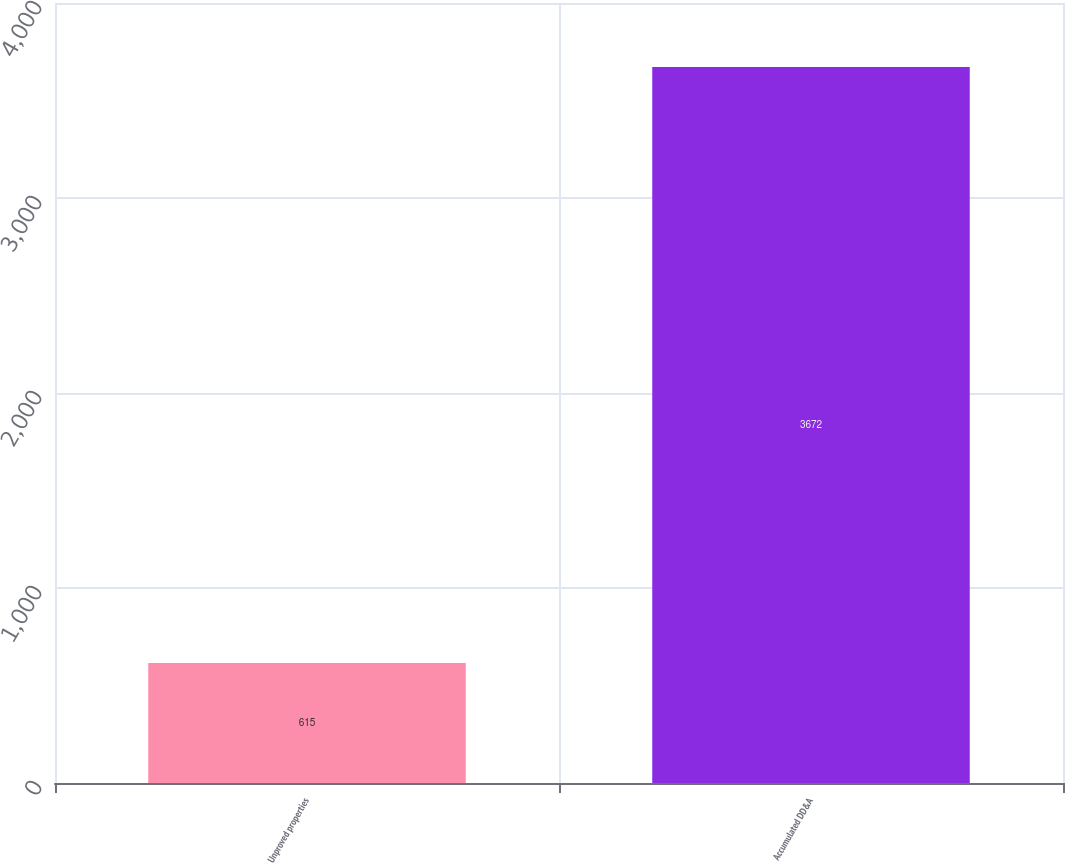<chart> <loc_0><loc_0><loc_500><loc_500><bar_chart><fcel>Unproved properties<fcel>Accumulated DD&A<nl><fcel>615<fcel>3672<nl></chart> 